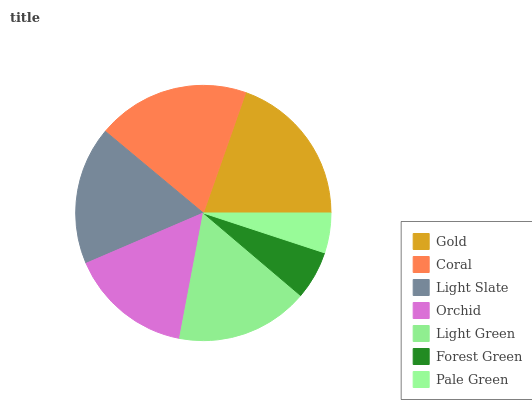Is Pale Green the minimum?
Answer yes or no. Yes. Is Gold the maximum?
Answer yes or no. Yes. Is Coral the minimum?
Answer yes or no. No. Is Coral the maximum?
Answer yes or no. No. Is Gold greater than Coral?
Answer yes or no. Yes. Is Coral less than Gold?
Answer yes or no. Yes. Is Coral greater than Gold?
Answer yes or no. No. Is Gold less than Coral?
Answer yes or no. No. Is Light Green the high median?
Answer yes or no. Yes. Is Light Green the low median?
Answer yes or no. Yes. Is Gold the high median?
Answer yes or no. No. Is Light Slate the low median?
Answer yes or no. No. 